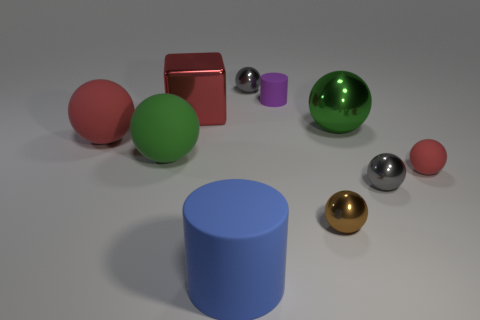What shapes are present in the image? The image displays a variety of geometric shapes, including spheres, a cube, a cylinder, and what appears to be a truncated cone or similar object. 